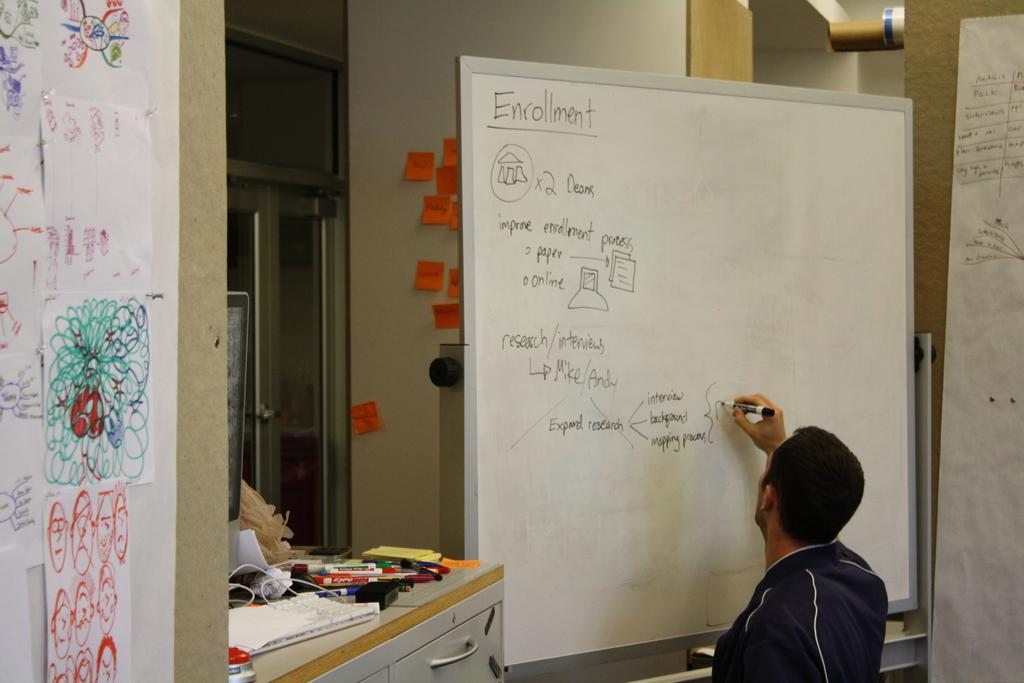What is the main header of this man's list on the board?
Keep it short and to the point. Enrollment. 